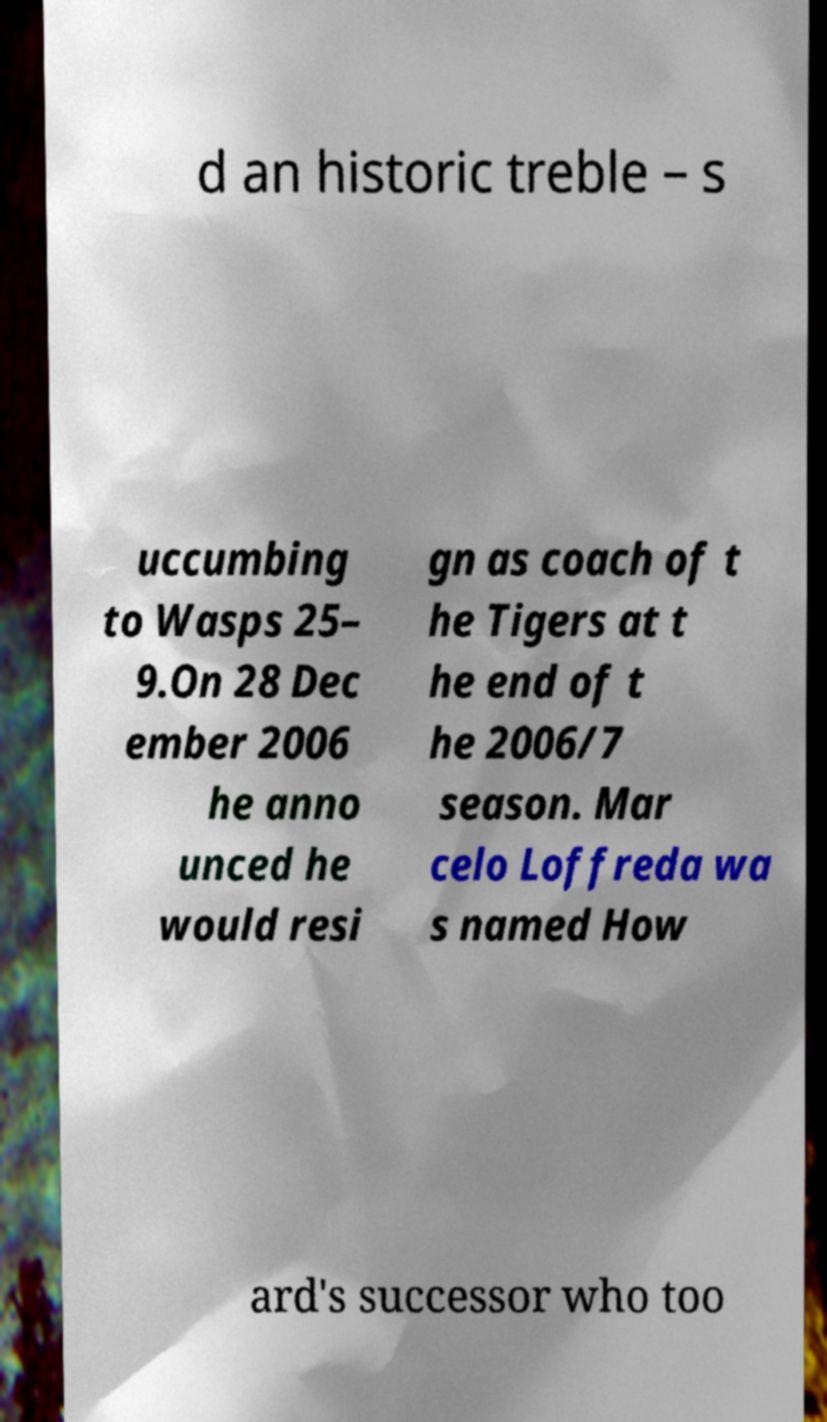What messages or text are displayed in this image? I need them in a readable, typed format. d an historic treble – s uccumbing to Wasps 25– 9.On 28 Dec ember 2006 he anno unced he would resi gn as coach of t he Tigers at t he end of t he 2006/7 season. Mar celo Loffreda wa s named How ard's successor who too 